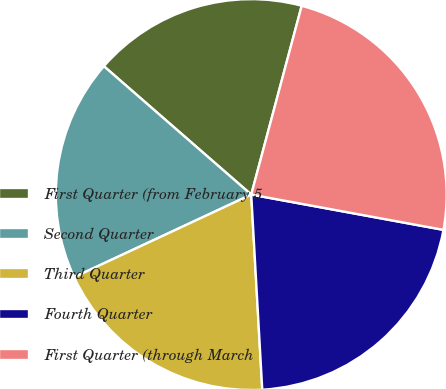Convert chart. <chart><loc_0><loc_0><loc_500><loc_500><pie_chart><fcel>First Quarter (from February 5<fcel>Second Quarter<fcel>Third Quarter<fcel>Fourth Quarter<fcel>First Quarter (through March<nl><fcel>17.75%<fcel>18.35%<fcel>18.95%<fcel>21.21%<fcel>23.73%<nl></chart> 